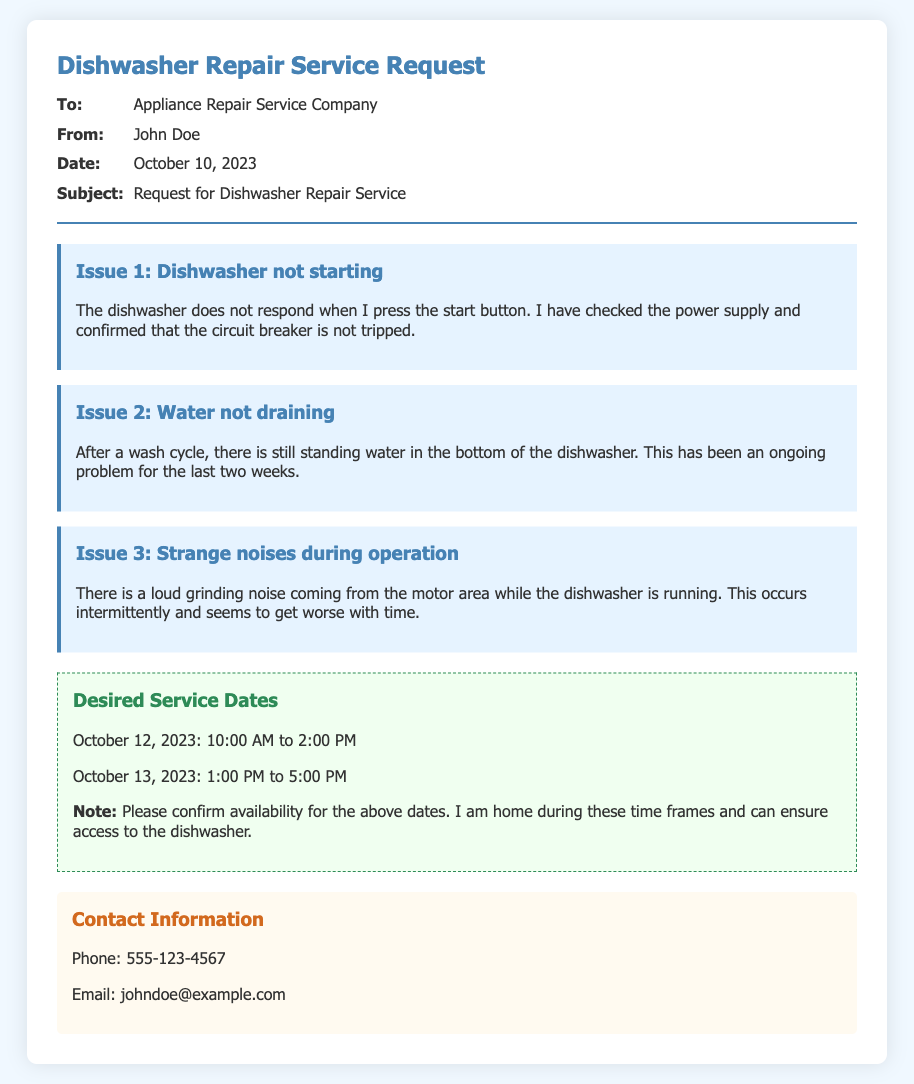what is the name of the person requesting the service? The memo states that the request is from John Doe.
Answer: John Doe what is the date of the request? The date mentioned in the memo is when the request was made.
Answer: October 10, 2023 what is the first issue listed in the memo? The memo details three issues, with the first being about the dishwasher not starting.
Answer: Dishwasher not starting what are the desired service dates? The document specifies two dates and their associated time frames for service requests.
Answer: October 12, 2023: 10:00 AM to 2:00 PM; October 13, 2023: 1:00 PM to 5:00 PM how can the requester be contacted? The memo provides contact information including a phone number and an email address.
Answer: Phone: 555-123-4567; Email: johndoe@example.com what noise issue is described in the memo? The memo mentions a specific type of noise issue occurring during operation, requiring attention.
Answer: Loud grinding noise which company is the service request directed to? The recipient of the memo is specified in the introductory section of the document.
Answer: Appliance Repair Service Company how many issues are described in the document? The number of issues detailed in the memo indicates the complexity of the repair request.
Answer: Three 